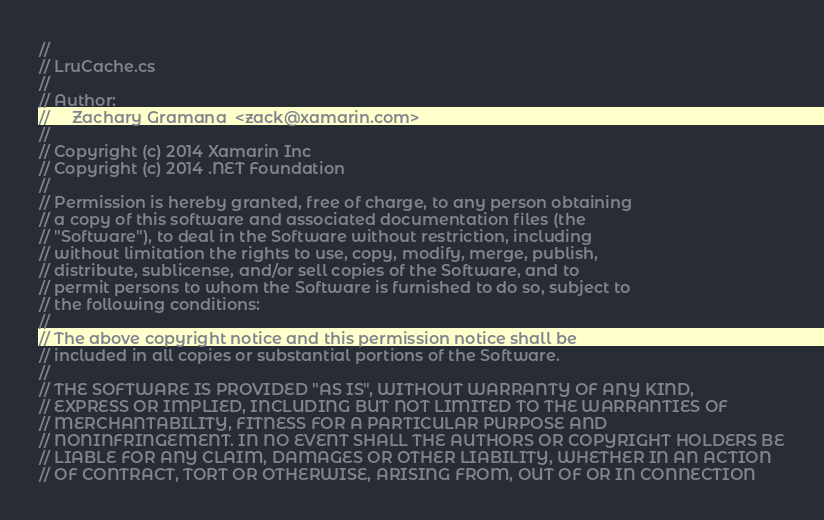Convert code to text. <code><loc_0><loc_0><loc_500><loc_500><_C#_>//
// LruCache.cs
//
// Author:
//     Zachary Gramana  <zack@xamarin.com>
//
// Copyright (c) 2014 Xamarin Inc
// Copyright (c) 2014 .NET Foundation
//
// Permission is hereby granted, free of charge, to any person obtaining
// a copy of this software and associated documentation files (the
// "Software"), to deal in the Software without restriction, including
// without limitation the rights to use, copy, modify, merge, publish,
// distribute, sublicense, and/or sell copies of the Software, and to
// permit persons to whom the Software is furnished to do so, subject to
// the following conditions:
// 
// The above copyright notice and this permission notice shall be
// included in all copies or substantial portions of the Software.
// 
// THE SOFTWARE IS PROVIDED "AS IS", WITHOUT WARRANTY OF ANY KIND,
// EXPRESS OR IMPLIED, INCLUDING BUT NOT LIMITED TO THE WARRANTIES OF
// MERCHANTABILITY, FITNESS FOR A PARTICULAR PURPOSE AND
// NONINFRINGEMENT. IN NO EVENT SHALL THE AUTHORS OR COPYRIGHT HOLDERS BE
// LIABLE FOR ANY CLAIM, DAMAGES OR OTHER LIABILITY, WHETHER IN AN ACTION
// OF CONTRACT, TORT OR OTHERWISE, ARISING FROM, OUT OF OR IN CONNECTION</code> 